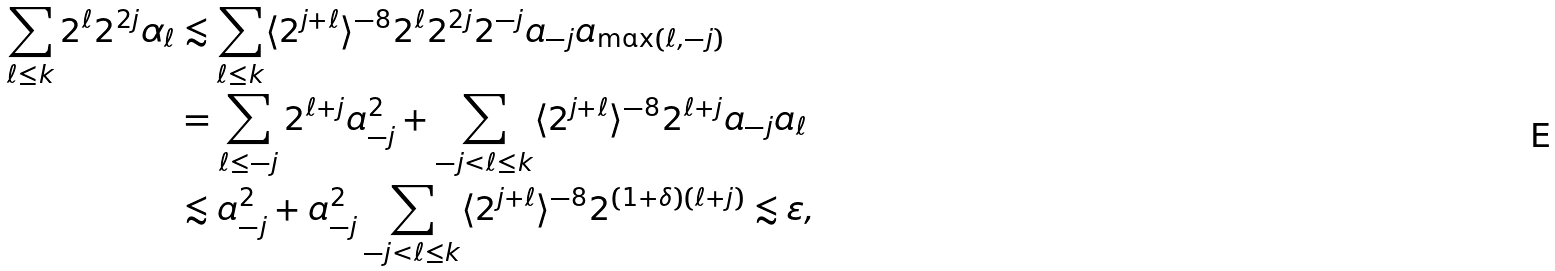<formula> <loc_0><loc_0><loc_500><loc_500>\sum _ { \ell \leq k } 2 ^ { \ell } 2 ^ { 2 j } \alpha _ { \ell } & \lesssim \sum _ { \ell \leq k } \langle 2 ^ { j + \ell } \rangle ^ { - 8 } 2 ^ { \ell } 2 ^ { 2 j } 2 ^ { - j } a _ { - j } a _ { \max ( \ell , - j ) } \\ & = \sum _ { \ell \leq - j } 2 ^ { \ell + j } a _ { - j } ^ { 2 } + \sum _ { - j < \ell \leq k } \langle 2 ^ { j + \ell } \rangle ^ { - 8 } 2 ^ { \ell + j } a _ { - j } a _ { \ell } \\ & \lesssim a _ { - j } ^ { 2 } + a _ { - j } ^ { 2 } \sum _ { - j < \ell \leq k } \langle 2 ^ { j + \ell } \rangle ^ { - 8 } 2 ^ { ( 1 + \delta ) ( \ell + j ) } \lesssim \varepsilon ,</formula> 